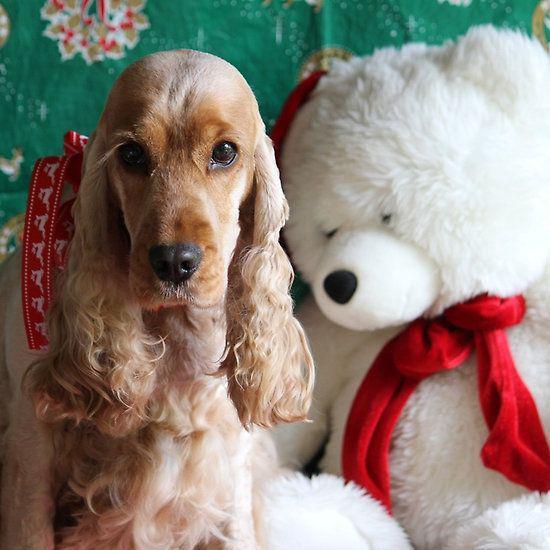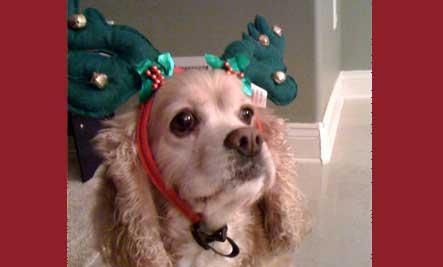The first image is the image on the left, the second image is the image on the right. Evaluate the accuracy of this statement regarding the images: "There are only two dogs in total.". Is it true? Answer yes or no. Yes. The first image is the image on the left, the second image is the image on the right. Given the left and right images, does the statement "Two spaniels are next to each other on a sofa in one image, and the other image shows one puppy in the foreground." hold true? Answer yes or no. No. 